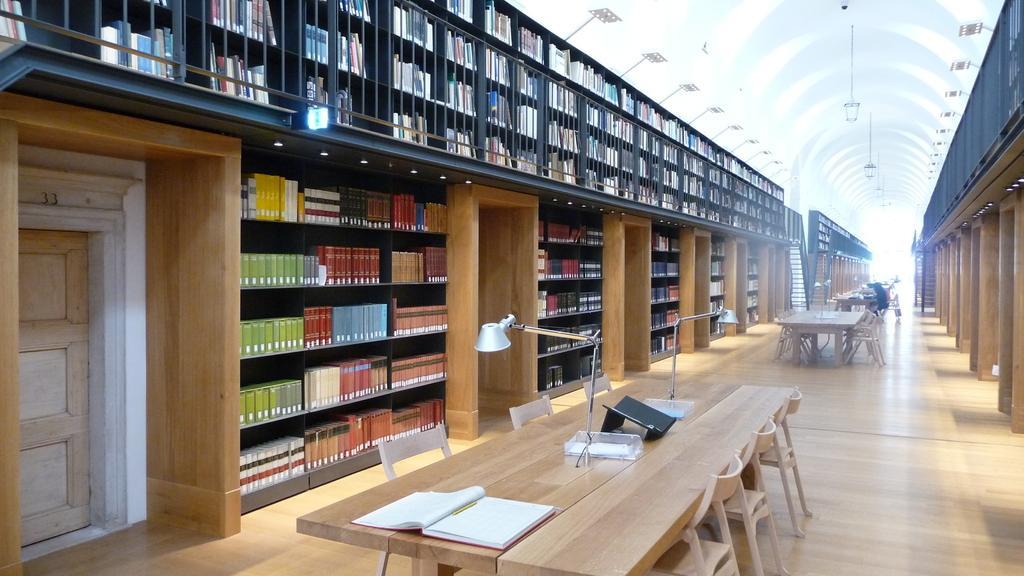Please provide a concise description of this image. In this picture there is a table with book and pen on it and on the left there are books arranged in the Shelf and here we can find some people sitting and reading 